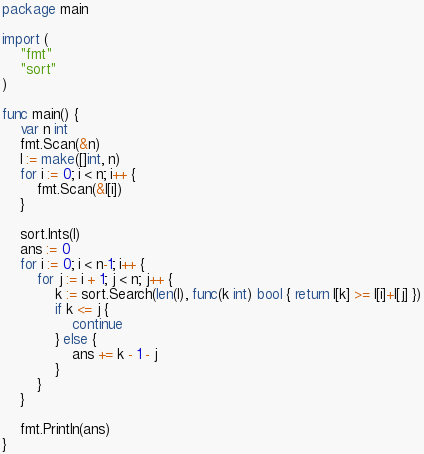<code> <loc_0><loc_0><loc_500><loc_500><_Go_>package main

import (
	"fmt"
	"sort"
)

func main() {
	var n int
	fmt.Scan(&n)
	l := make([]int, n)
	for i := 0; i < n; i++ {
		fmt.Scan(&l[i])
	}

	sort.Ints(l)
	ans := 0
	for i := 0; i < n-1; i++ {
		for j := i + 1; j < n; j++ {
			k := sort.Search(len(l), func(k int) bool { return l[k] >= l[i]+l[j] })
			if k <= j {
				continue
			} else {
				ans += k - 1 - j
			}
		}
	}

	fmt.Println(ans)
}
</code> 